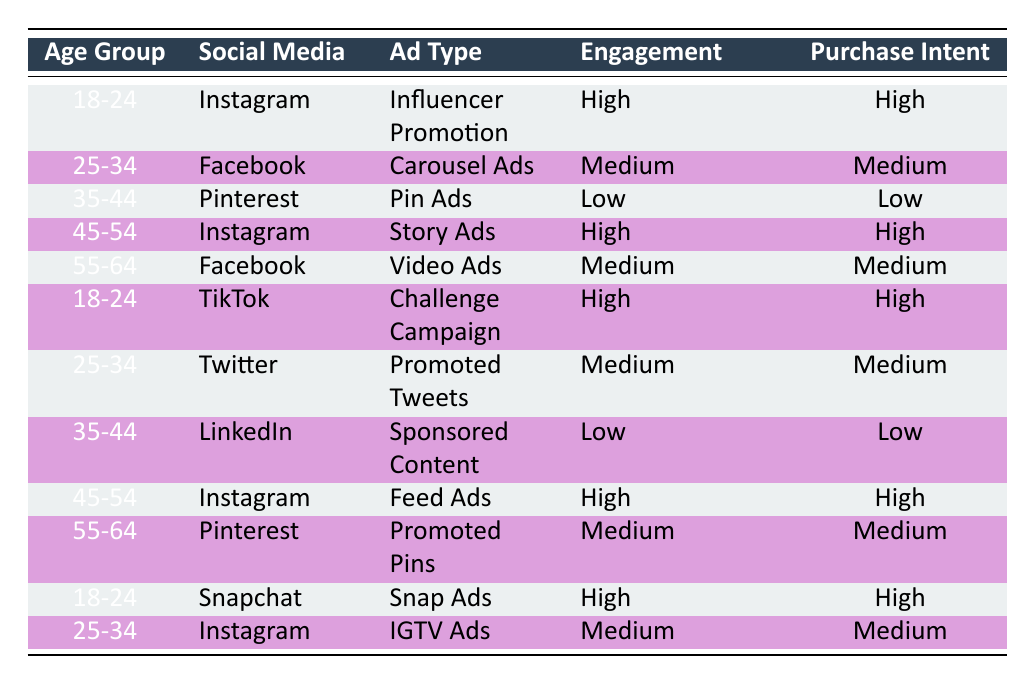What is the purchase intent for the 25-34 age group on Facebook? The table shows that for the 25-34 age group on Facebook, the purchase intent is categorized as Medium.
Answer: Medium How many high engagement ads result in high purchase intent? The table shows three instances where high engagement corresponds to high purchase intent: Instagram for the 18-24 age group (Influencer Promotion), Instagram for the 45-54 age group (Story Ads), and Snapchat for the 18-24 age group (Snap Ads). Therefore, there are three high engagement ads that lead to high purchase intent.
Answer: 3 Is the engagement level for the 35-44 age group consistently low across all platforms listed? The engagements for the 35-44 age group are listed as Low for both Pinterest (Pin Ads) and LinkedIn (Sponsored Content). This indicates that the engagement level is consistently low across the platforms for this age group.
Answer: Yes What age group has the highest number of ads with high engagement? The age group 18-24 displays high engagement in three instances: Instagram (Influencer Promotion), TikTok (Challenge Campaign), and Snapchat (Snap Ads). No other age group has more than two high engagement ads, so 18-24 has the highest.
Answer: 18-24 What is the average purchase intent level for the age group 55-64? From the table, the purchase intents for the age group 55-64 are Medium (Facebook Video Ads) and Medium (Pinterest Promoted Pins). Therefore, averaging these two Medium purchase intents results in Medium as a consistent level for this age group.
Answer: Medium Is there any ad type that leads to high purchase intent for the age group 35-44? Referring to the table, the ad type for the age group 35-44 on both listed platforms (Pinterest and LinkedIn) results in low purchase intent. Therefore, there are no ad types leading to high purchase intent for this age group.
Answer: No Which social media platform has the lowest engagement level in the table? The table indicates that both Pinterest and LinkedIn for the age group 35-44 have low engagement levels, making them the platforms with the lowest engagement in this dataset.
Answer: Pinterest and LinkedIn Are there any age groups that show a rise in both ad engagement and purchase intent? The data shows that the age groups 18-24 and 45-54 show high engagement with corresponding high purchase intent on platforms like Instagram and Snapchat. Thus, there is a rise in both metrics for these age groups.
Answer: Yes 